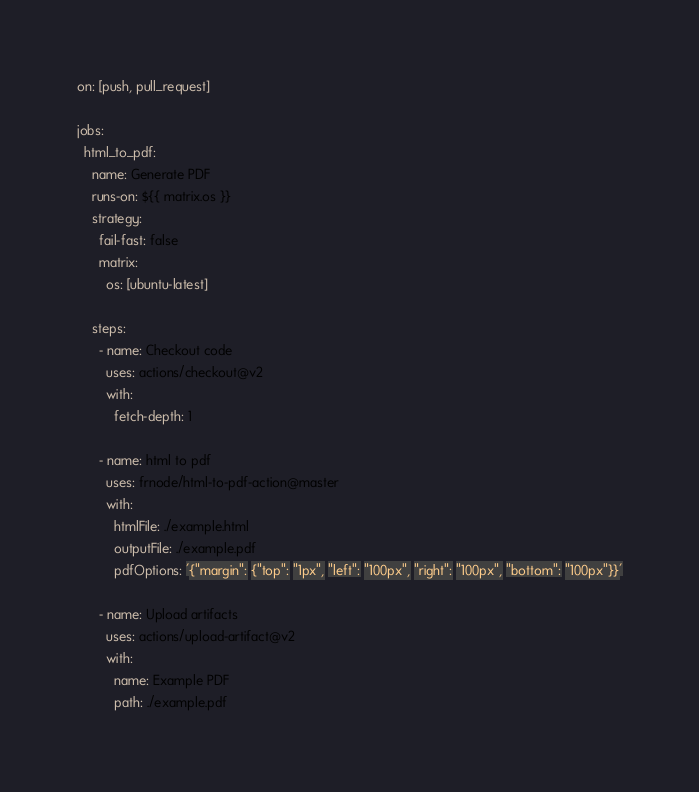Convert code to text. <code><loc_0><loc_0><loc_500><loc_500><_YAML_>
on: [push, pull_request]

jobs:
  html_to_pdf:
    name: Generate PDF
    runs-on: ${{ matrix.os }}
    strategy:
      fail-fast: false
      matrix:
        os: [ubuntu-latest]

    steps:
      - name: Checkout code
        uses: actions/checkout@v2
        with:
          fetch-depth: 1

      - name: html to pdf
        uses: frnode/html-to-pdf-action@master
        with:
          htmlFile: ./example.html
          outputFile: ./example.pdf
          pdfOptions: '{"margin": {"top": "1px", "left": "100px", "right": "100px", "bottom": "100px"}}'

      - name: Upload artifacts
        uses: actions/upload-artifact@v2
        with:
          name: Example PDF
          path: ./example.pdf</code> 